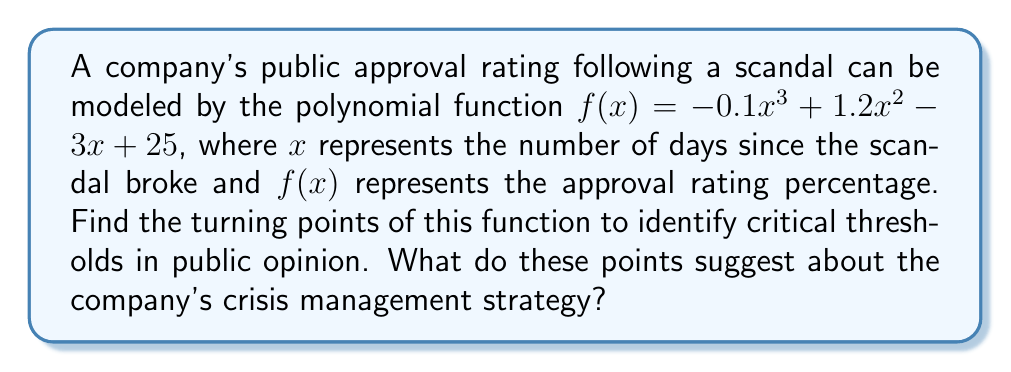Show me your answer to this math problem. To find the turning points, we need to follow these steps:

1) Find the derivative of the function:
   $f'(x) = -0.3x^2 + 2.4x - 3$

2) Set the derivative equal to zero and solve for x:
   $-0.3x^2 + 2.4x - 3 = 0$

3) This is a quadratic equation. We can solve it using the quadratic formula:
   $x = \frac{-b \pm \sqrt{b^2 - 4ac}}{2a}$

   Where $a = -0.3$, $b = 2.4$, and $c = -3$

4) Plugging in these values:
   $x = \frac{-2.4 \pm \sqrt{2.4^2 - 4(-0.3)(-3)}}{2(-0.3)}$
   $= \frac{-2.4 \pm \sqrt{5.76 - 3.6}}{-0.6}$
   $= \frac{-2.4 \pm \sqrt{2.16}}{-0.6}$
   $= \frac{-2.4 \pm 1.47}{-0.6}$

5) This gives us two solutions:
   $x_1 = \frac{-2.4 + 1.47}{-0.6} = 1.55$
   $x_2 = \frac{-2.4 - 1.47}{-0.6} = 6.45$

6) To find the y-coordinates, we plug these x-values back into the original function:
   $f(1.55) \approx 23.95$
   $f(6.45) \approx 30.05$

Therefore, the turning points are approximately (1.55, 23.95) and (6.45, 30.05).

These points suggest that the company's approval rating reaches a local minimum around 1.55 days after the scandal, then rises to a local maximum around 6.45 days after. This implies that the initial negative reaction peaks early, but the company's crisis management strategy may be effective in improving public opinion over the following days.
Answer: Turning points: (1.55, 23.95) and (6.45, 30.05) 